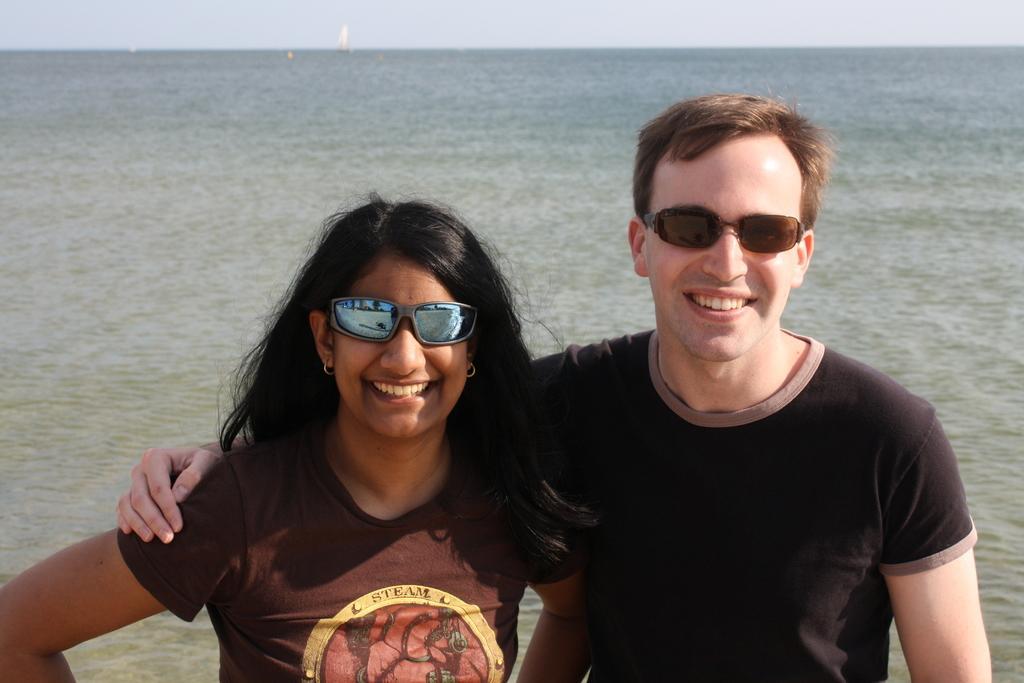In one or two sentences, can you explain what this image depicts? Here we can see two people. These two people are smiling and wore goggles. Background there is a water and sky. 